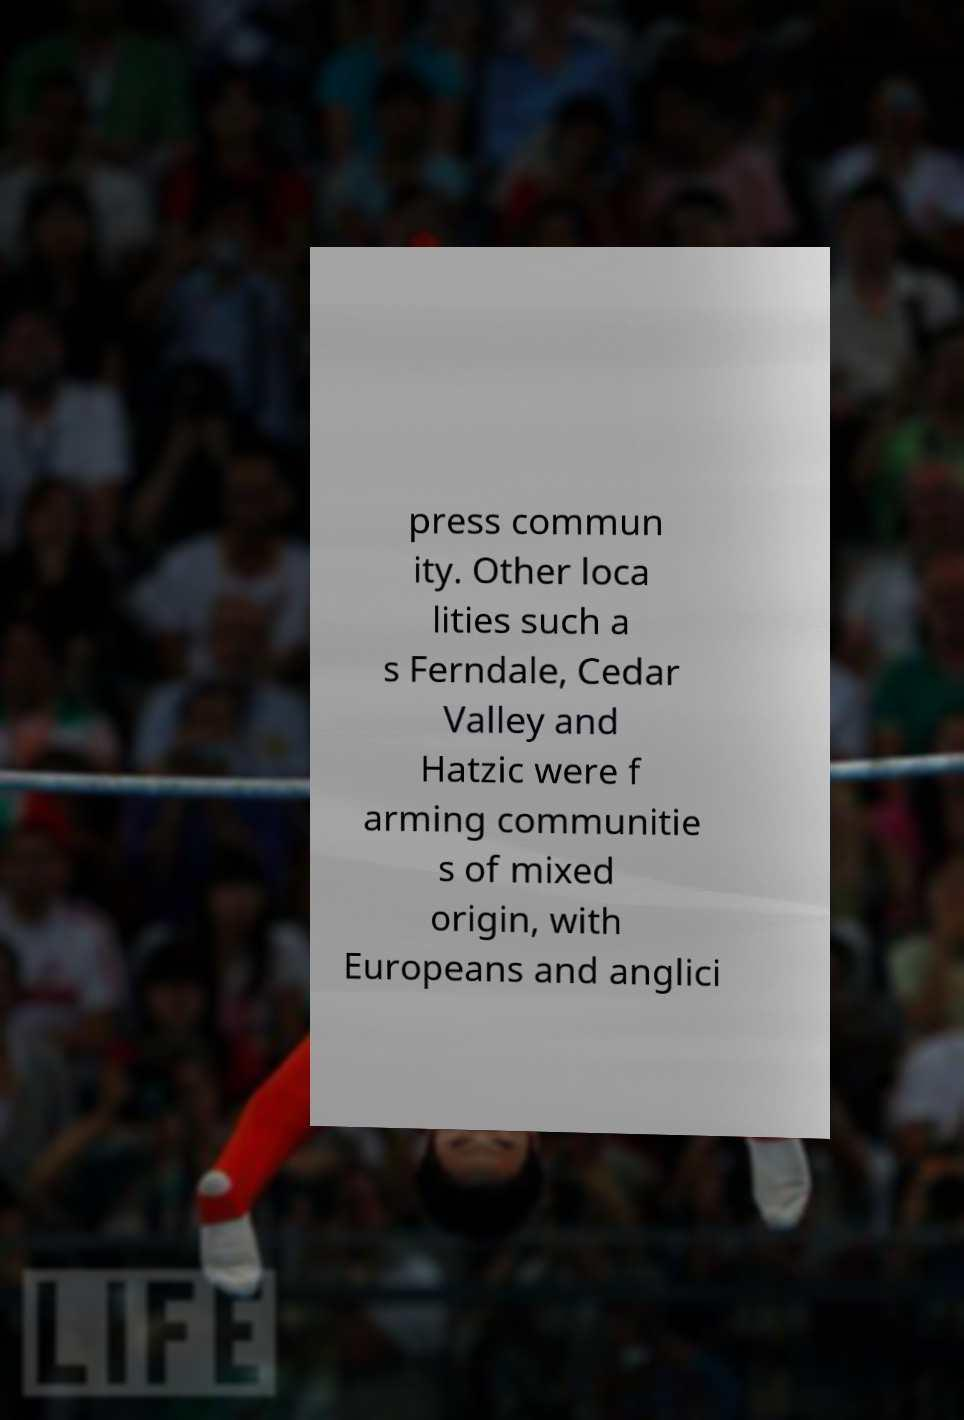Can you accurately transcribe the text from the provided image for me? press commun ity. Other loca lities such a s Ferndale, Cedar Valley and Hatzic were f arming communitie s of mixed origin, with Europeans and anglici 